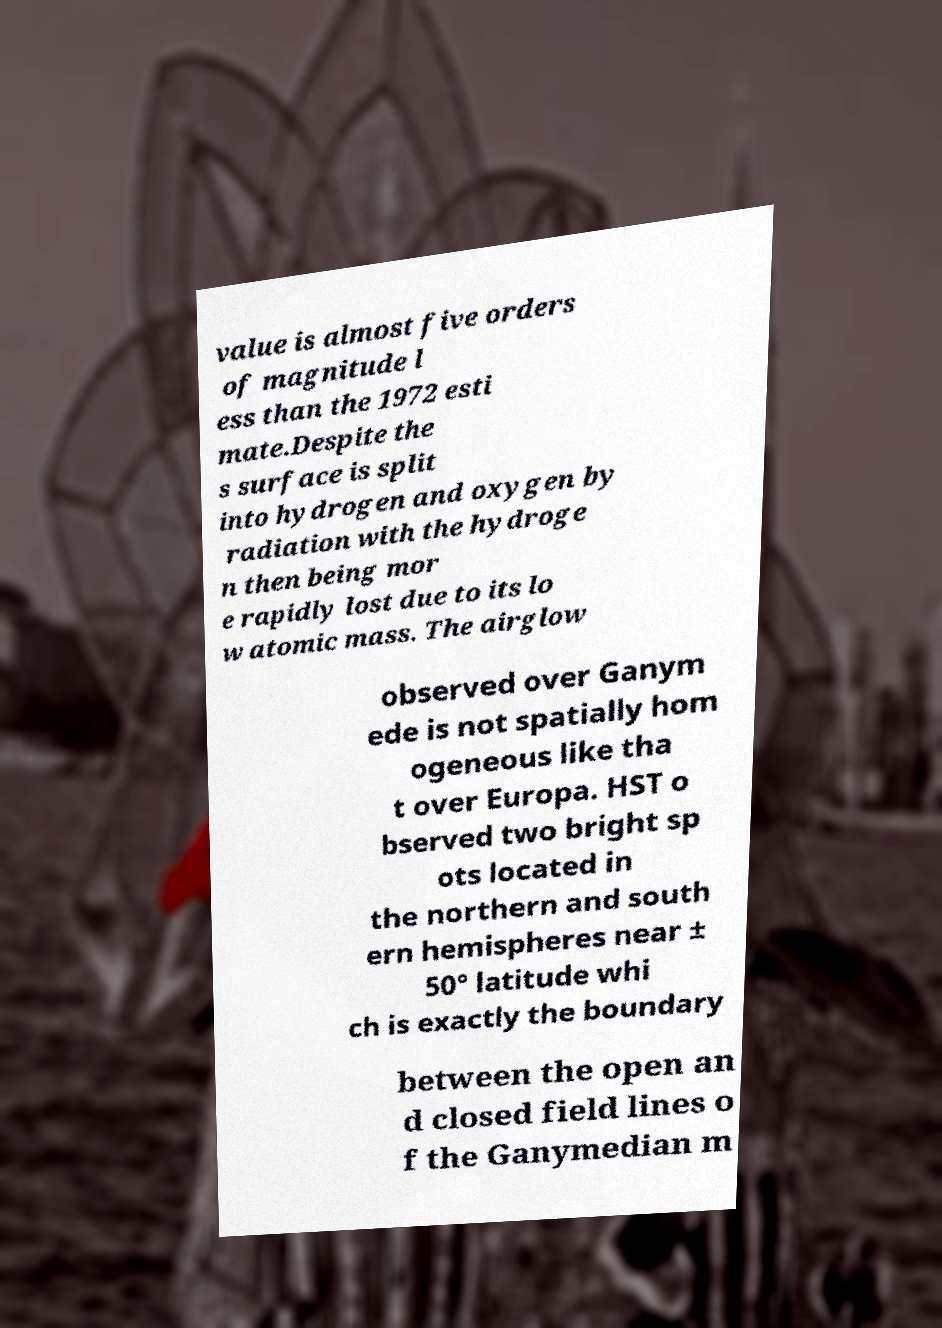Could you assist in decoding the text presented in this image and type it out clearly? value is almost five orders of magnitude l ess than the 1972 esti mate.Despite the s surface is split into hydrogen and oxygen by radiation with the hydroge n then being mor e rapidly lost due to its lo w atomic mass. The airglow observed over Ganym ede is not spatially hom ogeneous like tha t over Europa. HST o bserved two bright sp ots located in the northern and south ern hemispheres near ± 50° latitude whi ch is exactly the boundary between the open an d closed field lines o f the Ganymedian m 